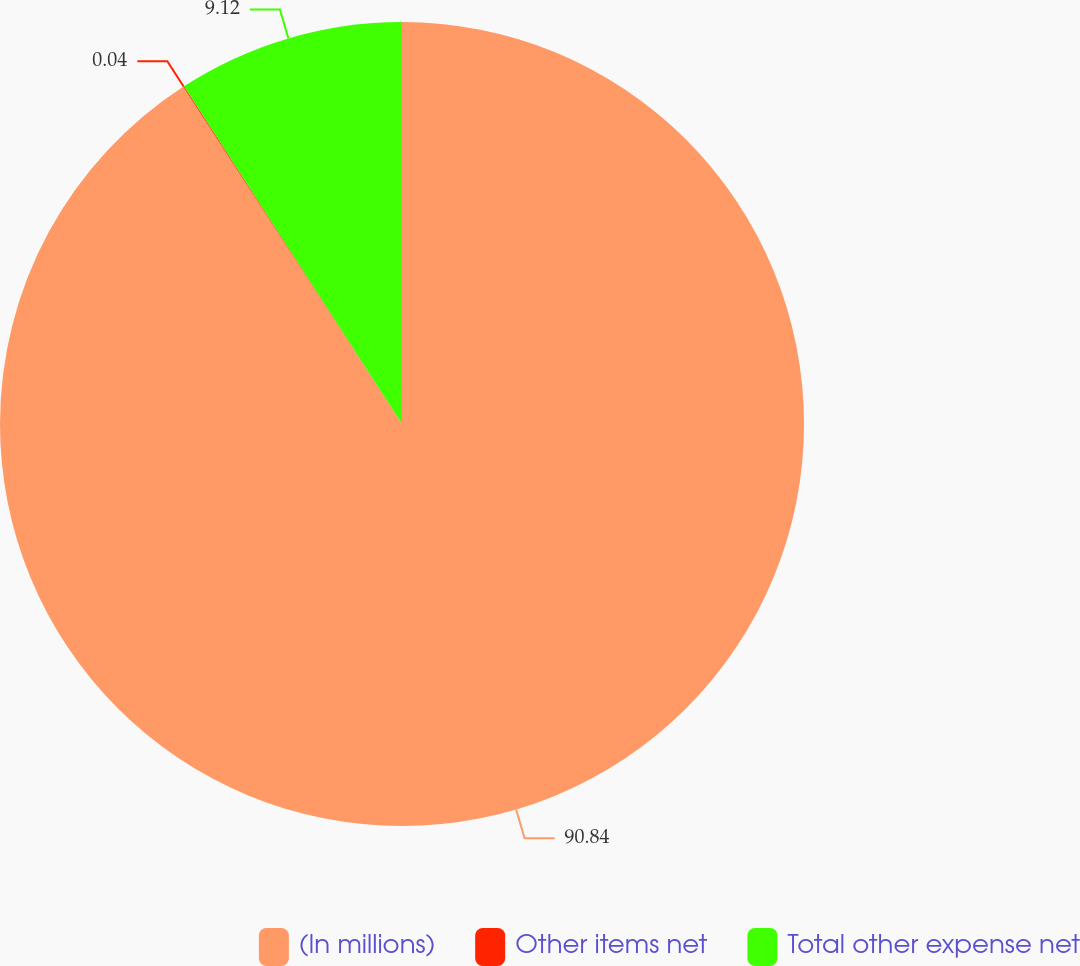Convert chart to OTSL. <chart><loc_0><loc_0><loc_500><loc_500><pie_chart><fcel>(In millions)<fcel>Other items net<fcel>Total other expense net<nl><fcel>90.84%<fcel>0.04%<fcel>9.12%<nl></chart> 